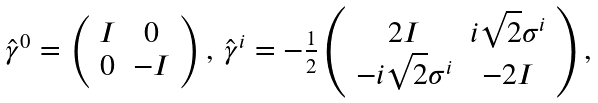<formula> <loc_0><loc_0><loc_500><loc_500>\begin{array} { c c } \hat { \gamma } ^ { 0 } = \left ( \begin{array} { c c } I & 0 \\ 0 & - I \\ \end{array} \right ) , \, \hat { \gamma } ^ { i } = - \frac { 1 } { 2 } \left ( \begin{array} { c c } 2 I & i \sqrt { 2 } \sigma ^ { i } \\ - i \sqrt { 2 } \sigma ^ { i } & - 2 I \\ \end{array} \right ) , \end{array}</formula> 